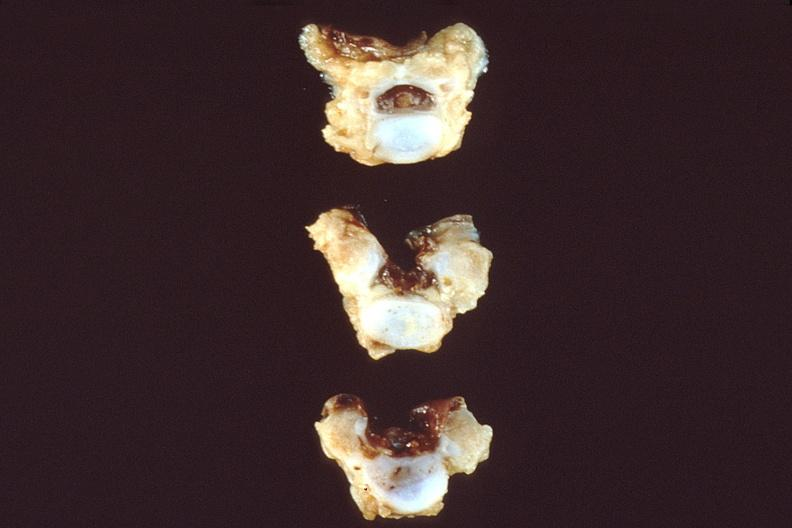s nervous present?
Answer the question using a single word or phrase. Yes 